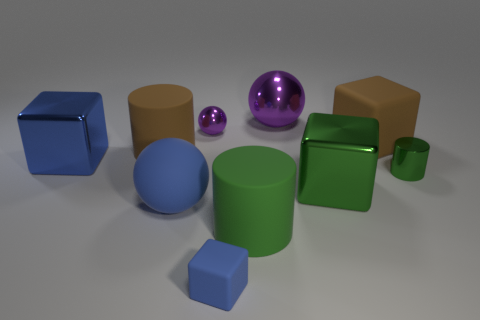There is a big metallic object that is the same color as the small cylinder; what shape is it?
Your answer should be very brief. Cube. Does the matte sphere have the same color as the large shiny thing that is left of the brown cylinder?
Give a very brief answer. Yes. Are there any large matte balls of the same color as the tiny cube?
Your response must be concise. Yes. There is a thing that is the same color as the big matte block; what size is it?
Make the answer very short. Large. Are there any small blue things made of the same material as the large blue block?
Make the answer very short. No. What number of things are either brown things that are on the left side of the blue rubber sphere or metallic things that are behind the big brown cube?
Your answer should be very brief. 3. Do the small blue thing and the large brown rubber thing right of the tiny shiny ball have the same shape?
Give a very brief answer. Yes. How many other objects are there of the same shape as the tiny blue thing?
Provide a short and direct response. 3. What number of things are tiny purple things or small cyan metal things?
Give a very brief answer. 1. Is the small metal ball the same color as the large metallic sphere?
Offer a terse response. Yes. 